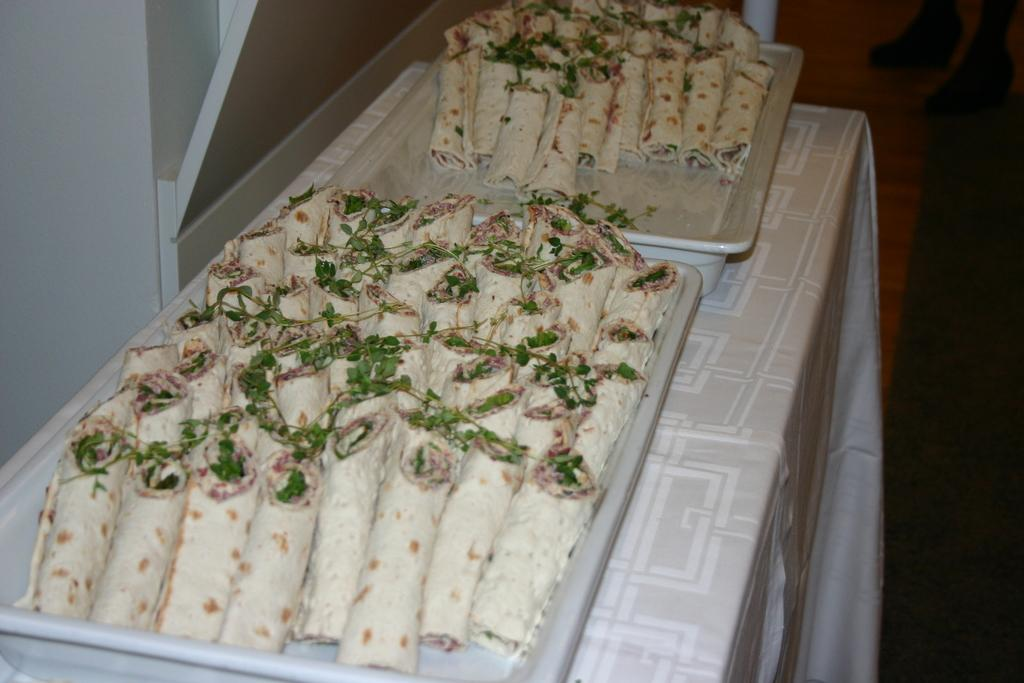What is on the tray that is visible in the image? There are food items on a tray in the image. Where is the tray located? The tray is placed on a table. What color is the tablecloth on the table? The tablecloth on the table is white. How would you describe the lighting in the image? The background of the image is dark. What is the tendency of the pencil to float in the image? There is no pencil present in the image, so it is not possible to determine its tendency to float. 